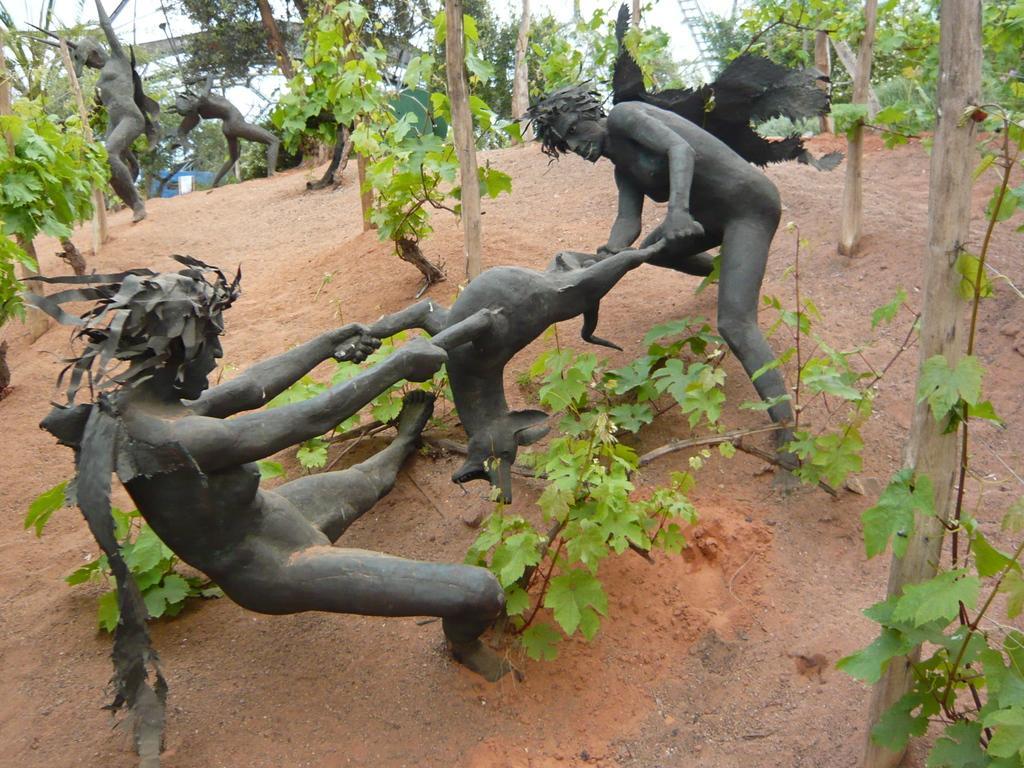Could you give a brief overview of what you see in this image? In the image,there are black sculptures of people and animals and around them there are some plants. 